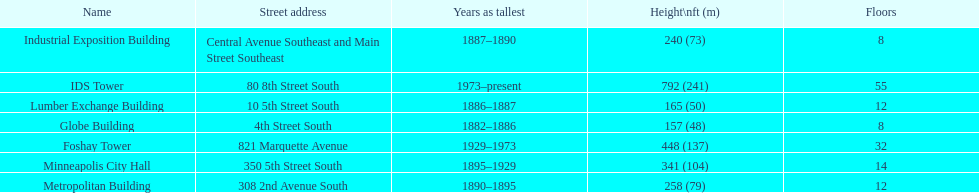How tall is it to the top of the ids tower in feet? 792. 